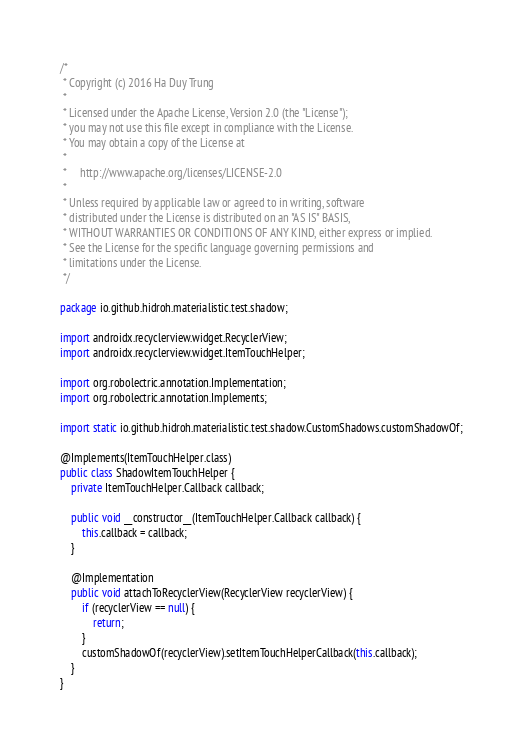<code> <loc_0><loc_0><loc_500><loc_500><_Java_>/*
 * Copyright (c) 2016 Ha Duy Trung
 *
 * Licensed under the Apache License, Version 2.0 (the "License");
 * you may not use this file except in compliance with the License.
 * You may obtain a copy of the License at
 *
 *     http://www.apache.org/licenses/LICENSE-2.0
 *
 * Unless required by applicable law or agreed to in writing, software
 * distributed under the License is distributed on an "AS IS" BASIS,
 * WITHOUT WARRANTIES OR CONDITIONS OF ANY KIND, either express or implied.
 * See the License for the specific language governing permissions and
 * limitations under the License.
 */

package io.github.hidroh.materialistic.test.shadow;

import androidx.recyclerview.widget.RecyclerView;
import androidx.recyclerview.widget.ItemTouchHelper;

import org.robolectric.annotation.Implementation;
import org.robolectric.annotation.Implements;

import static io.github.hidroh.materialistic.test.shadow.CustomShadows.customShadowOf;

@Implements(ItemTouchHelper.class)
public class ShadowItemTouchHelper {
    private ItemTouchHelper.Callback callback;

    public void __constructor__(ItemTouchHelper.Callback callback) {
        this.callback = callback;
    }

    @Implementation
    public void attachToRecyclerView(RecyclerView recyclerView) {
        if (recyclerView == null) {
            return;
        }
        customShadowOf(recyclerView).setItemTouchHelperCallback(this.callback);
    }
}
</code> 